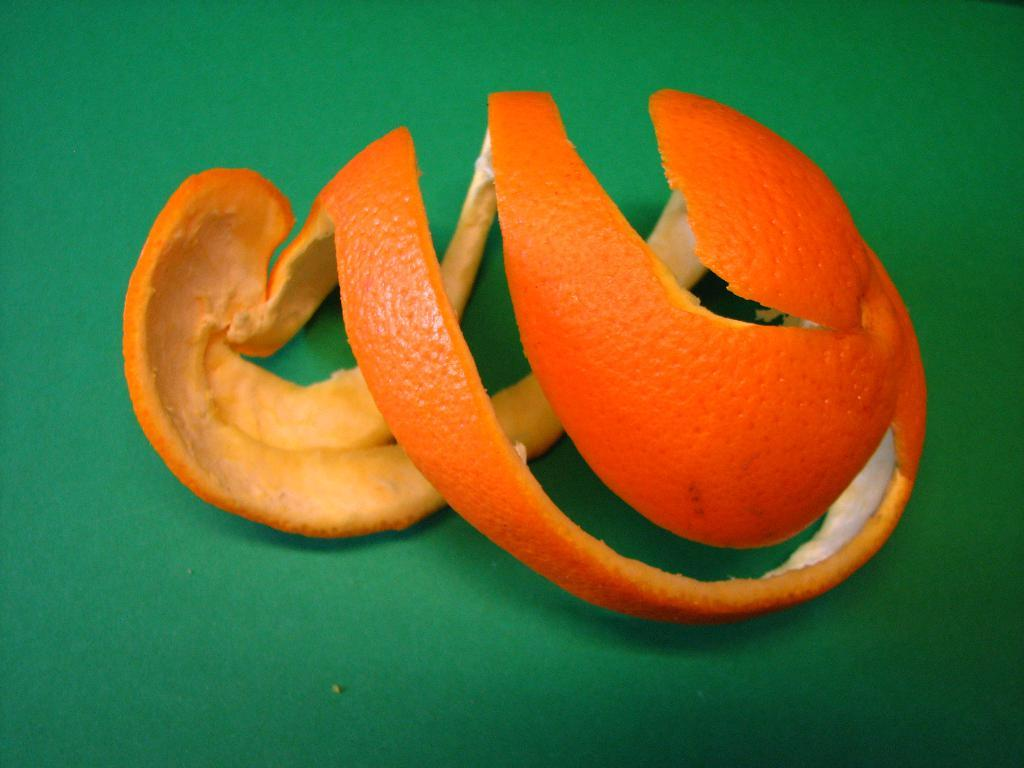What is the main subject of the image? The main subject of the image is an orange peel. What is the color of the orange peel? The orange peel is orange in color. On what surface is the orange peel placed? The orange peel is on a green surface. What type of idea is being discussed by the governor at the market in the image? There is no governor, market, or discussion present in the image; it only features an orange peel on a green surface. 